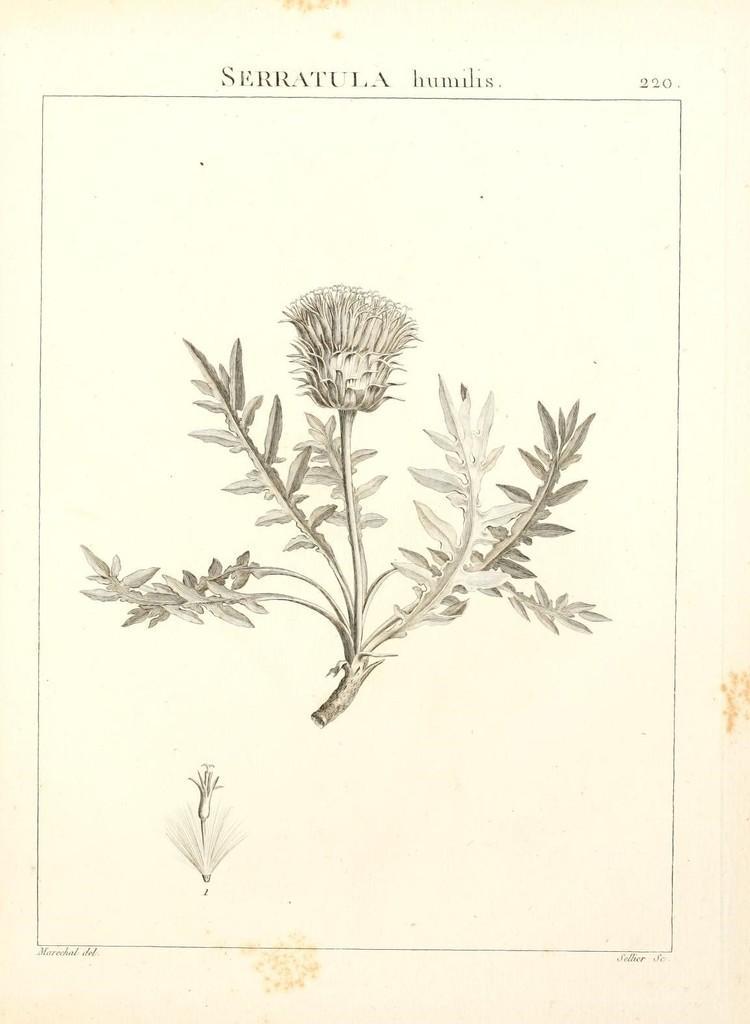Please provide a concise description of this image. In this image in the center there is drawing of a plant, and at the top and bottom of the image there is text. 